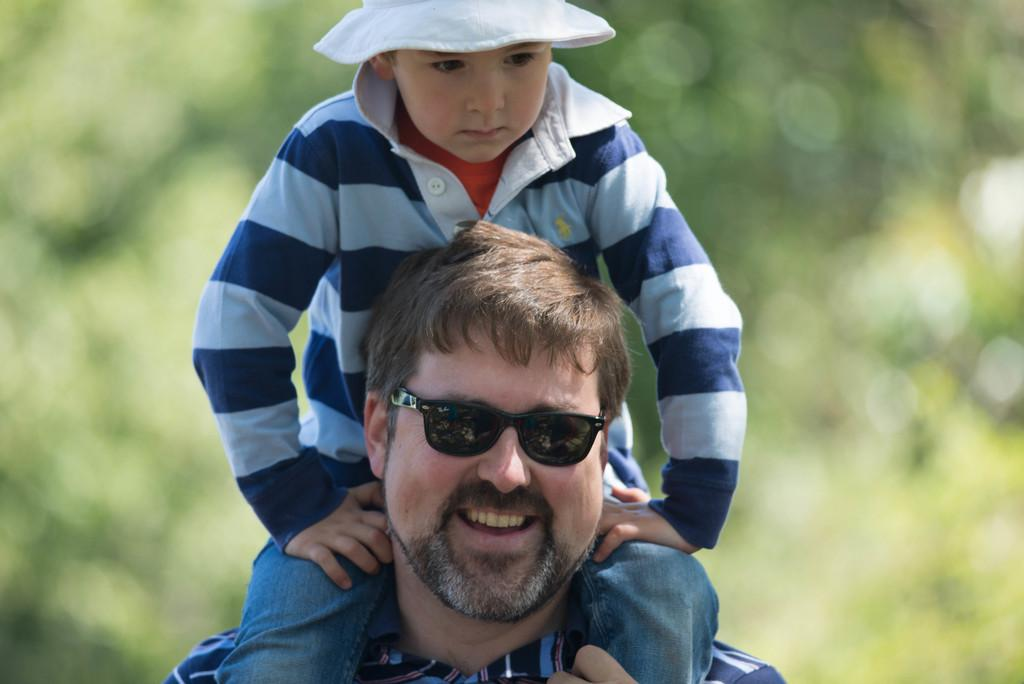What is the main subject of the image? The main subject of the image is a man. What is the man doing in the image? The man is carrying a boy on his shoulders. What is the man's facial expression in the image? The man is smiling in the image. What is the man wearing on his face? The man is wearing black goggles in the image. What can be observed about the background in the image? The background of the man is blurred in the image. What type of patch is sewn onto the boy's shirt in the image? There is no boy present in the image, and therefore no shirt or patch can be observed. What is the son's reaction to the cannon in the image? There is no son or cannon present in the image. 